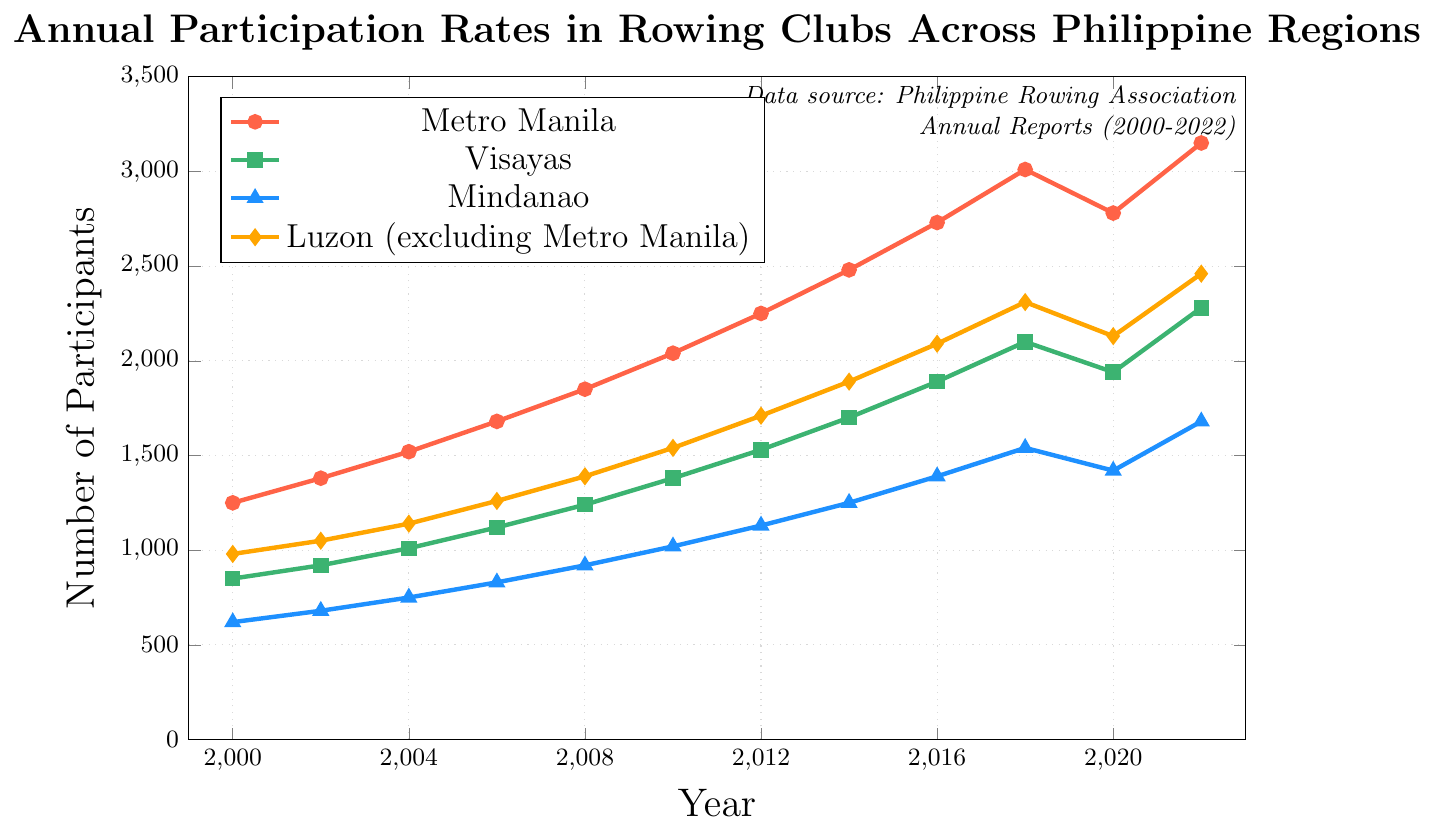What region had the highest participation rate in 2022? Check the data points for each region in 2022: Metro Manila (3150), Visayas (2280), Mindanao (1680), Luzon (excluding Metro Manila) (2460). Metro Manila has the highest value.
Answer: Metro Manila What was the participation rate in Metro Manila in 2018 compared to 2020? Look at the data points for Metro Manila in 2018 (3010) and 2020 (2780). 3010 is greater than 2780, indicating a decline.
Answer: 3010 vs 2780 How much did participation in Mindanao increase from 2000 to 2022? Subtract Mindanao's 2000 value from its 2022 value: 1680 - 620 = 1060.
Answer: 1060 Which region had the least growth in participation from 2018 to 2020? Calculate the difference for each region from 2018 to 2020: Metro Manila (3010 to 2780) = -230, Visayas (2100 to 1940) = -160, Mindanao (1540 to 1420) = -120, Luzon (2310 to 2130) = -180. Mindanao had the smallest decline.
Answer: Mindanao By how much did participation in rowing clubs in Luzon (excluding Metro Manila) increase from 2000 to 2022? Subtract Luzon's 2000 value from its 2022 value: 2460 - 980 = 1480.
Answer: 1480 Between what years did Visayas experience the highest rate of increase in participants? Examine the differences between consecutive years for Visayas. The highest increase is from 2018 (2100) to 2022 (2280): 2280 - 2100 = 180.
Answer: 2018 to 2022 Which region experienced the most significant decline in participation from 2018 to 2020? Look at the drop for each region between 2018 and 2020: Metro Manila (3010 to 2780) = -230, Visayas (2100 to 1940) = -160, Mindanao (1540 to 1420) = -120, Luzon (2310 to 2130) = -180. Metro Manila had the largest decline.
Answer: Metro Manila Which region had a consistent increase in participation throughout the entire period from 2000 to 2022 without any decreases? Analyze the trends for each region. All regions have at least one decrease except Visayas.
Answer: Visayas What's the average participation rate in Visayas over the given years? Sum Visayas' values and divide by the number of years: (850 + 920 + 1010 + 1120 + 1240 + 1380 + 1530 + 1700 + 1890 + 2100 + 1940 + 2280) / 12 = 1519.67.
Answer: 1519.67 Which region saw the highest percentage increase from 2000 to 2022? Calculate the percentage increase for each region: 
- Metro Manila: (3150 - 1250) / 1250 * 100 = 152%
- Visayas: (2280 - 850) / 850 * 100 = 168%
- Mindanao: (1680 - 620) / 620 * 100 = 171%
- Luzon: (2460 - 980) / 980 * 100 = 151%. 
Mindanao has the highest percentage increase.
Answer: Mindanao 